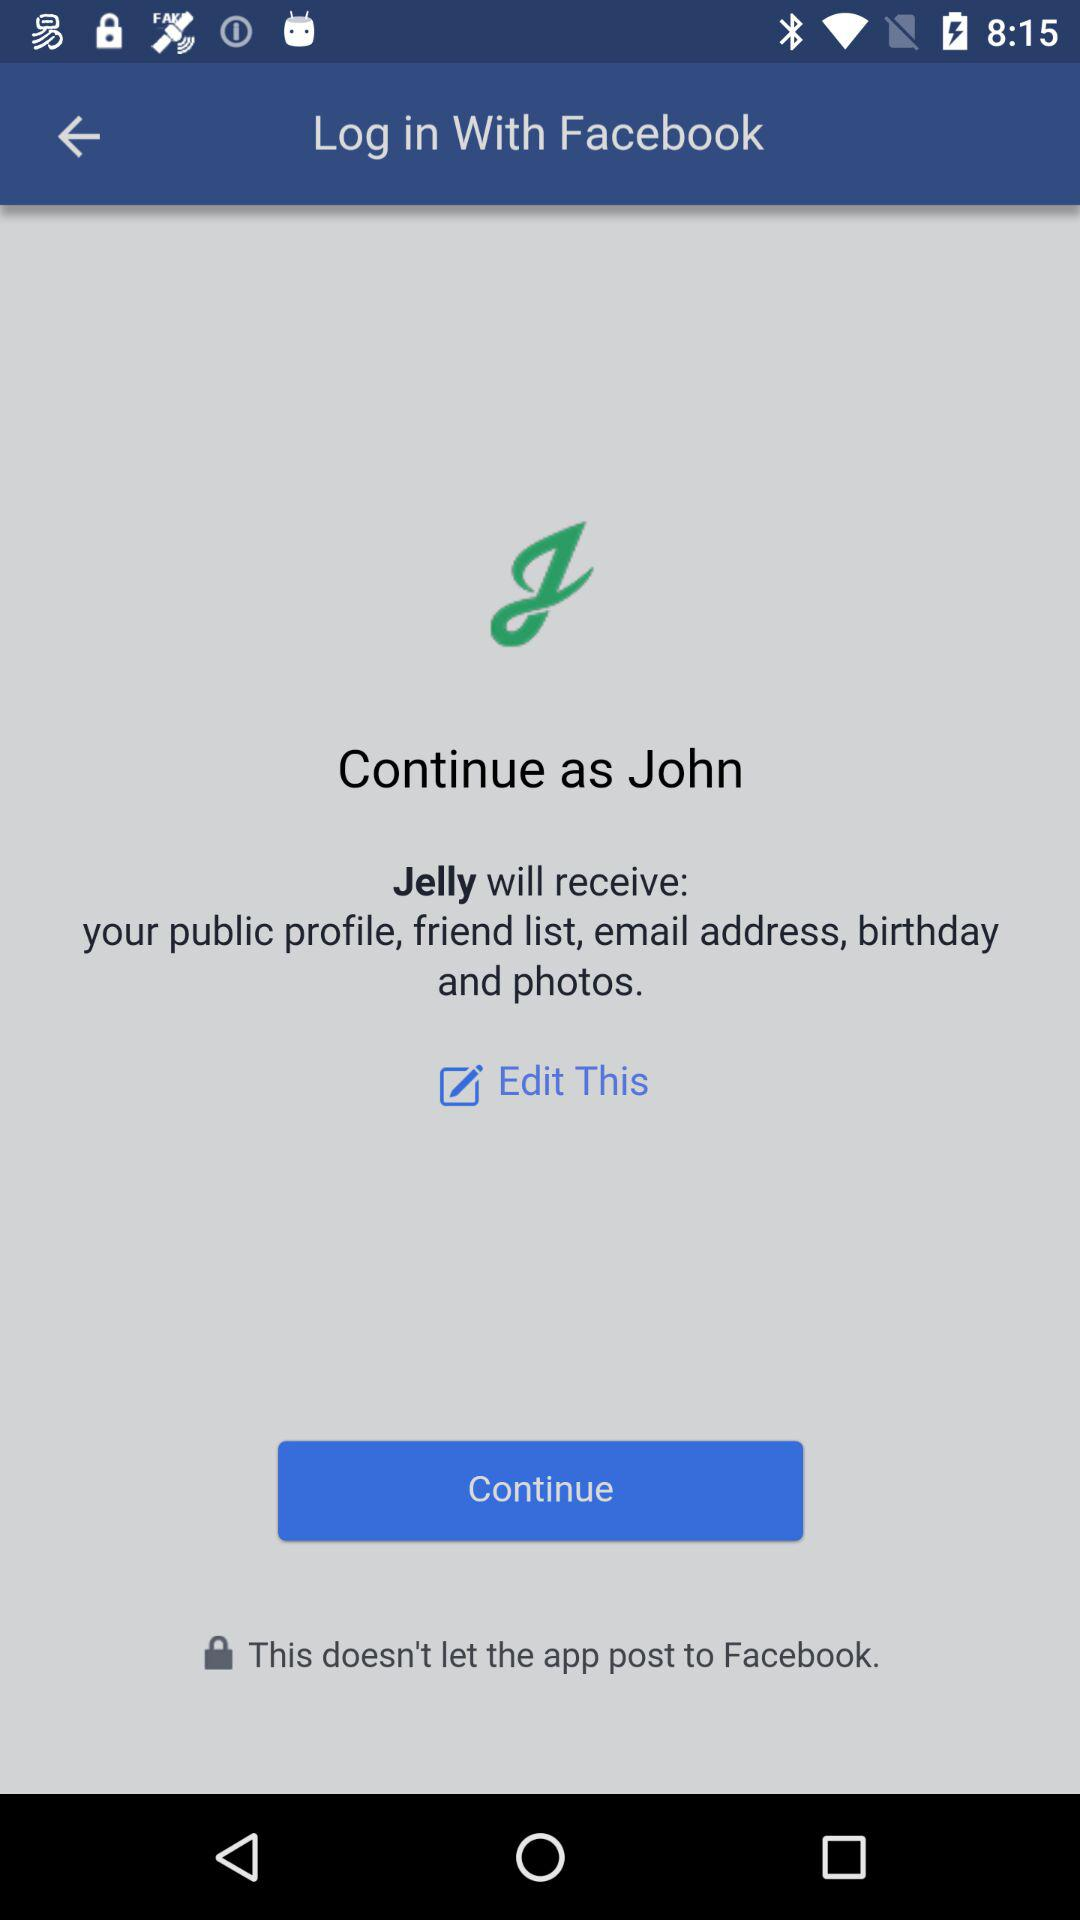What applications can we log in with? You can log in with "Facebook". 